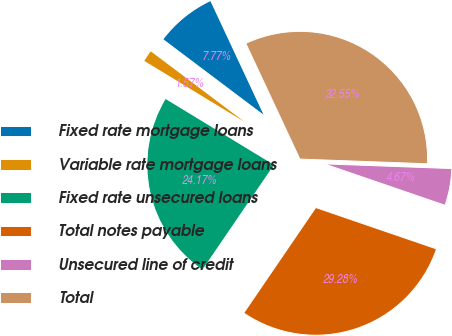<chart> <loc_0><loc_0><loc_500><loc_500><pie_chart><fcel>Fixed rate mortgage loans<fcel>Variable rate mortgage loans<fcel>Fixed rate unsecured loans<fcel>Total notes payable<fcel>Unsecured line of credit<fcel>Total<nl><fcel>7.77%<fcel>1.57%<fcel>24.17%<fcel>29.28%<fcel>4.67%<fcel>32.55%<nl></chart> 